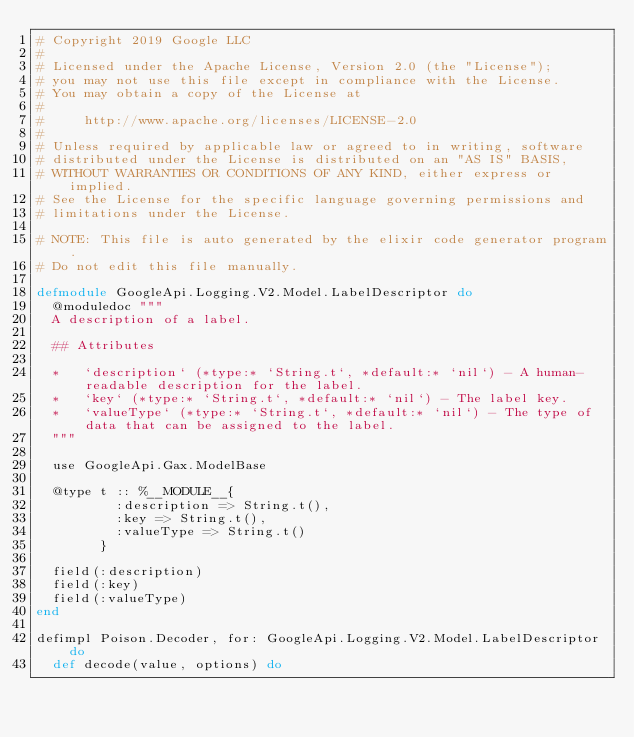<code> <loc_0><loc_0><loc_500><loc_500><_Elixir_># Copyright 2019 Google LLC
#
# Licensed under the Apache License, Version 2.0 (the "License");
# you may not use this file except in compliance with the License.
# You may obtain a copy of the License at
#
#     http://www.apache.org/licenses/LICENSE-2.0
#
# Unless required by applicable law or agreed to in writing, software
# distributed under the License is distributed on an "AS IS" BASIS,
# WITHOUT WARRANTIES OR CONDITIONS OF ANY KIND, either express or implied.
# See the License for the specific language governing permissions and
# limitations under the License.

# NOTE: This file is auto generated by the elixir code generator program.
# Do not edit this file manually.

defmodule GoogleApi.Logging.V2.Model.LabelDescriptor do
  @moduledoc """
  A description of a label.

  ## Attributes

  *   `description` (*type:* `String.t`, *default:* `nil`) - A human-readable description for the label.
  *   `key` (*type:* `String.t`, *default:* `nil`) - The label key.
  *   `valueType` (*type:* `String.t`, *default:* `nil`) - The type of data that can be assigned to the label.
  """

  use GoogleApi.Gax.ModelBase

  @type t :: %__MODULE__{
          :description => String.t(),
          :key => String.t(),
          :valueType => String.t()
        }

  field(:description)
  field(:key)
  field(:valueType)
end

defimpl Poison.Decoder, for: GoogleApi.Logging.V2.Model.LabelDescriptor do
  def decode(value, options) do</code> 